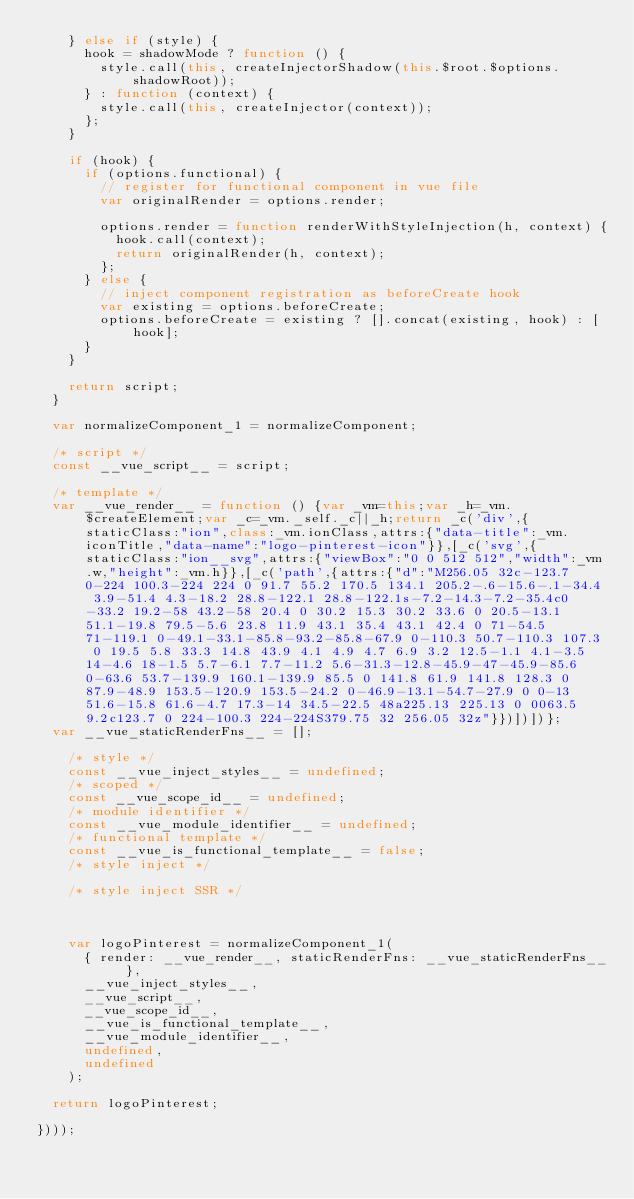<code> <loc_0><loc_0><loc_500><loc_500><_JavaScript_>    } else if (style) {
      hook = shadowMode ? function () {
        style.call(this, createInjectorShadow(this.$root.$options.shadowRoot));
      } : function (context) {
        style.call(this, createInjector(context));
      };
    }

    if (hook) {
      if (options.functional) {
        // register for functional component in vue file
        var originalRender = options.render;

        options.render = function renderWithStyleInjection(h, context) {
          hook.call(context);
          return originalRender(h, context);
        };
      } else {
        // inject component registration as beforeCreate hook
        var existing = options.beforeCreate;
        options.beforeCreate = existing ? [].concat(existing, hook) : [hook];
      }
    }

    return script;
  }

  var normalizeComponent_1 = normalizeComponent;

  /* script */
  const __vue_script__ = script;

  /* template */
  var __vue_render__ = function () {var _vm=this;var _h=_vm.$createElement;var _c=_vm._self._c||_h;return _c('div',{staticClass:"ion",class:_vm.ionClass,attrs:{"data-title":_vm.iconTitle,"data-name":"logo-pinterest-icon"}},[_c('svg',{staticClass:"ion__svg",attrs:{"viewBox":"0 0 512 512","width":_vm.w,"height":_vm.h}},[_c('path',{attrs:{"d":"M256.05 32c-123.7 0-224 100.3-224 224 0 91.7 55.2 170.5 134.1 205.2-.6-15.6-.1-34.4 3.9-51.4 4.3-18.2 28.8-122.1 28.8-122.1s-7.2-14.3-7.2-35.4c0-33.2 19.2-58 43.2-58 20.4 0 30.2 15.3 30.2 33.6 0 20.5-13.1 51.1-19.8 79.5-5.6 23.8 11.9 43.1 35.4 43.1 42.4 0 71-54.5 71-119.1 0-49.1-33.1-85.8-93.2-85.8-67.9 0-110.3 50.7-110.3 107.3 0 19.5 5.8 33.3 14.8 43.9 4.1 4.9 4.7 6.9 3.2 12.5-1.1 4.1-3.5 14-4.6 18-1.5 5.7-6.1 7.7-11.2 5.6-31.3-12.8-45.9-47-45.9-85.6 0-63.6 53.7-139.9 160.1-139.9 85.5 0 141.8 61.9 141.8 128.3 0 87.9-48.9 153.5-120.9 153.5-24.2 0-46.9-13.1-54.7-27.9 0 0-13 51.6-15.8 61.6-4.7 17.3-14 34.5-22.5 48a225.13 225.13 0 0063.5 9.2c123.7 0 224-100.3 224-224S379.75 32 256.05 32z"}})])])};
  var __vue_staticRenderFns__ = [];

    /* style */
    const __vue_inject_styles__ = undefined;
    /* scoped */
    const __vue_scope_id__ = undefined;
    /* module identifier */
    const __vue_module_identifier__ = undefined;
    /* functional template */
    const __vue_is_functional_template__ = false;
    /* style inject */
    
    /* style inject SSR */
    

    
    var logoPinterest = normalizeComponent_1(
      { render: __vue_render__, staticRenderFns: __vue_staticRenderFns__ },
      __vue_inject_styles__,
      __vue_script__,
      __vue_scope_id__,
      __vue_is_functional_template__,
      __vue_module_identifier__,
      undefined,
      undefined
    );

  return logoPinterest;

})));
</code> 